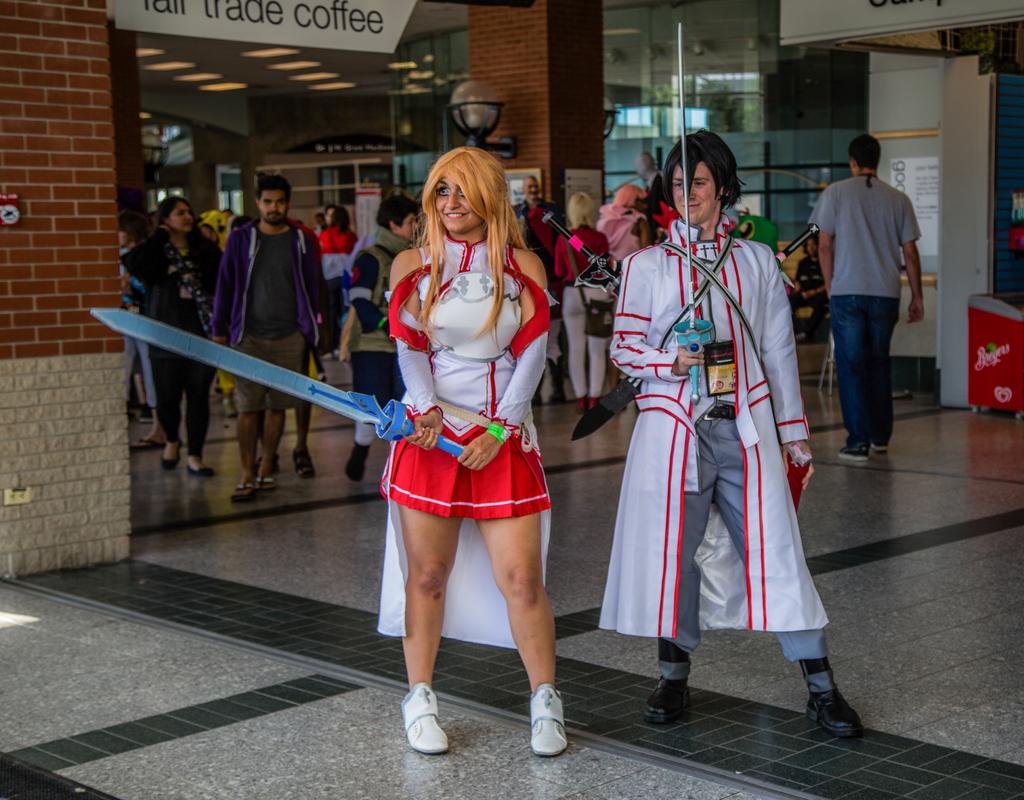Waht can you buy in the store in the left corner?
Ensure brevity in your answer.  Coffee. What hot beverage is on the banner in the background?
Your response must be concise. Coffee. 